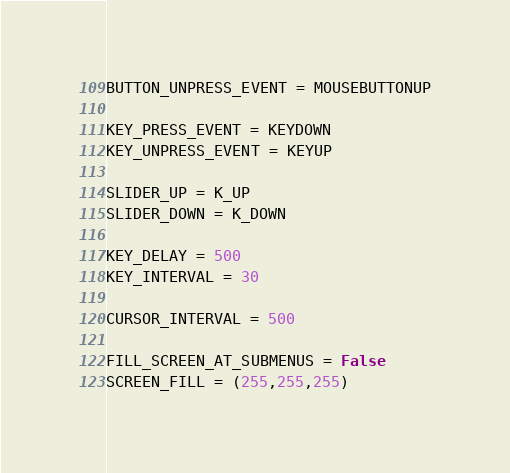Convert code to text. <code><loc_0><loc_0><loc_500><loc_500><_Python_>BUTTON_UNPRESS_EVENT = MOUSEBUTTONUP

KEY_PRESS_EVENT = KEYDOWN
KEY_UNPRESS_EVENT = KEYUP

SLIDER_UP = K_UP
SLIDER_DOWN = K_DOWN

KEY_DELAY = 500
KEY_INTERVAL = 30

CURSOR_INTERVAL = 500

FILL_SCREEN_AT_SUBMENUS = False
SCREEN_FILL = (255,255,255)</code> 